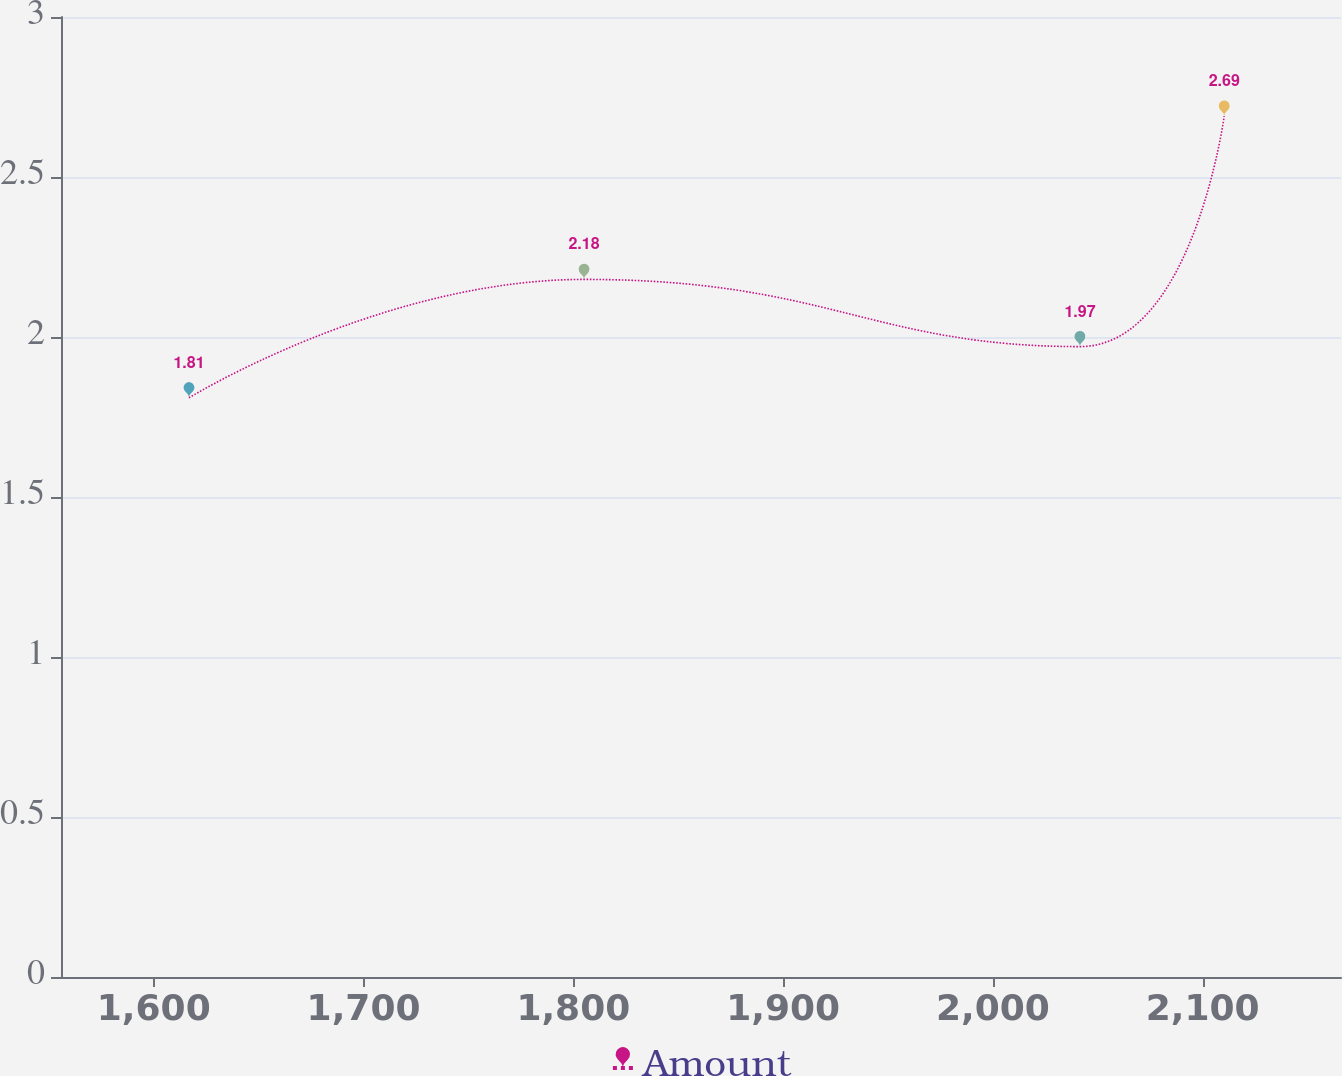Convert chart. <chart><loc_0><loc_0><loc_500><loc_500><line_chart><ecel><fcel>Amount<nl><fcel>1616.8<fcel>1.81<nl><fcel>1805.11<fcel>2.18<nl><fcel>2041.51<fcel>1.97<nl><fcel>2110.27<fcel>2.69<nl><fcel>2226.96<fcel>3.4<nl></chart> 